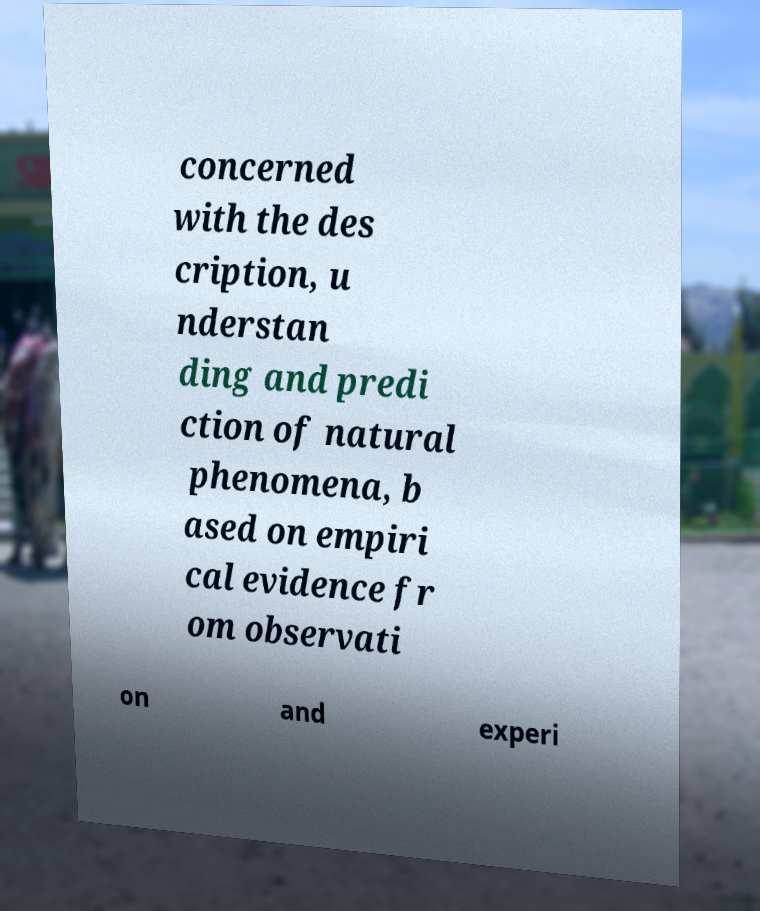There's text embedded in this image that I need extracted. Can you transcribe it verbatim? concerned with the des cription, u nderstan ding and predi ction of natural phenomena, b ased on empiri cal evidence fr om observati on and experi 